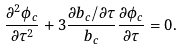<formula> <loc_0><loc_0><loc_500><loc_500>\frac { \partial ^ { 2 } \phi _ { c } } { \partial \tau ^ { 2 } } + 3 \frac { \partial b _ { c } / \partial \tau } { b _ { c } } \frac { \partial \phi _ { c } } { \partial \tau } = 0 .</formula> 